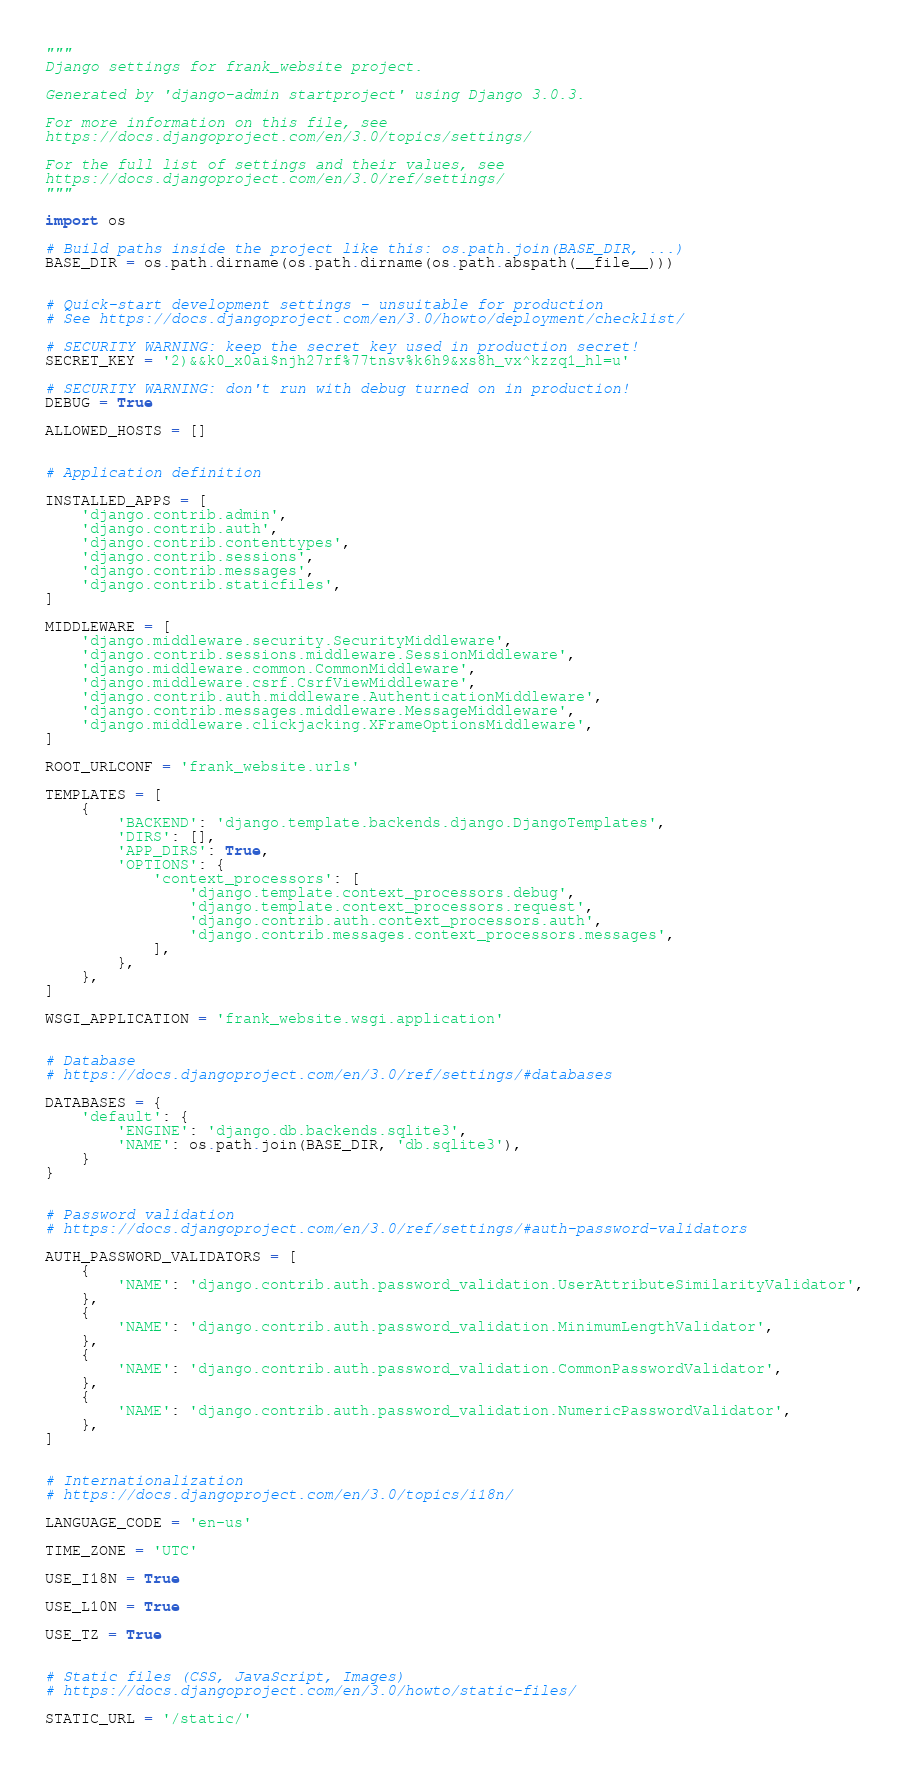<code> <loc_0><loc_0><loc_500><loc_500><_Python_>"""
Django settings for frank_website project.

Generated by 'django-admin startproject' using Django 3.0.3.

For more information on this file, see
https://docs.djangoproject.com/en/3.0/topics/settings/

For the full list of settings and their values, see
https://docs.djangoproject.com/en/3.0/ref/settings/
"""

import os

# Build paths inside the project like this: os.path.join(BASE_DIR, ...)
BASE_DIR = os.path.dirname(os.path.dirname(os.path.abspath(__file__)))


# Quick-start development settings - unsuitable for production
# See https://docs.djangoproject.com/en/3.0/howto/deployment/checklist/

# SECURITY WARNING: keep the secret key used in production secret!
SECRET_KEY = '2)&&k0_x0ai$njh27rf%77tnsv%k6h9&xs8h_vx^kzzq1_hl=u'

# SECURITY WARNING: don't run with debug turned on in production!
DEBUG = True

ALLOWED_HOSTS = []


# Application definition

INSTALLED_APPS = [
    'django.contrib.admin',
    'django.contrib.auth',
    'django.contrib.contenttypes',
    'django.contrib.sessions',
    'django.contrib.messages',
    'django.contrib.staticfiles',
]

MIDDLEWARE = [
    'django.middleware.security.SecurityMiddleware',
    'django.contrib.sessions.middleware.SessionMiddleware',
    'django.middleware.common.CommonMiddleware',
    'django.middleware.csrf.CsrfViewMiddleware',
    'django.contrib.auth.middleware.AuthenticationMiddleware',
    'django.contrib.messages.middleware.MessageMiddleware',
    'django.middleware.clickjacking.XFrameOptionsMiddleware',
]

ROOT_URLCONF = 'frank_website.urls'

TEMPLATES = [
    {
        'BACKEND': 'django.template.backends.django.DjangoTemplates',
        'DIRS': [],
        'APP_DIRS': True,
        'OPTIONS': {
            'context_processors': [
                'django.template.context_processors.debug',
                'django.template.context_processors.request',
                'django.contrib.auth.context_processors.auth',
                'django.contrib.messages.context_processors.messages',
            ],
        },
    },
]

WSGI_APPLICATION = 'frank_website.wsgi.application'


# Database
# https://docs.djangoproject.com/en/3.0/ref/settings/#databases

DATABASES = {
    'default': {
        'ENGINE': 'django.db.backends.sqlite3',
        'NAME': os.path.join(BASE_DIR, 'db.sqlite3'),
    }
}


# Password validation
# https://docs.djangoproject.com/en/3.0/ref/settings/#auth-password-validators

AUTH_PASSWORD_VALIDATORS = [
    {
        'NAME': 'django.contrib.auth.password_validation.UserAttributeSimilarityValidator',
    },
    {
        'NAME': 'django.contrib.auth.password_validation.MinimumLengthValidator',
    },
    {
        'NAME': 'django.contrib.auth.password_validation.CommonPasswordValidator',
    },
    {
        'NAME': 'django.contrib.auth.password_validation.NumericPasswordValidator',
    },
]


# Internationalization
# https://docs.djangoproject.com/en/3.0/topics/i18n/

LANGUAGE_CODE = 'en-us'

TIME_ZONE = 'UTC'

USE_I18N = True

USE_L10N = True

USE_TZ = True


# Static files (CSS, JavaScript, Images)
# https://docs.djangoproject.com/en/3.0/howto/static-files/

STATIC_URL = '/static/'
</code> 